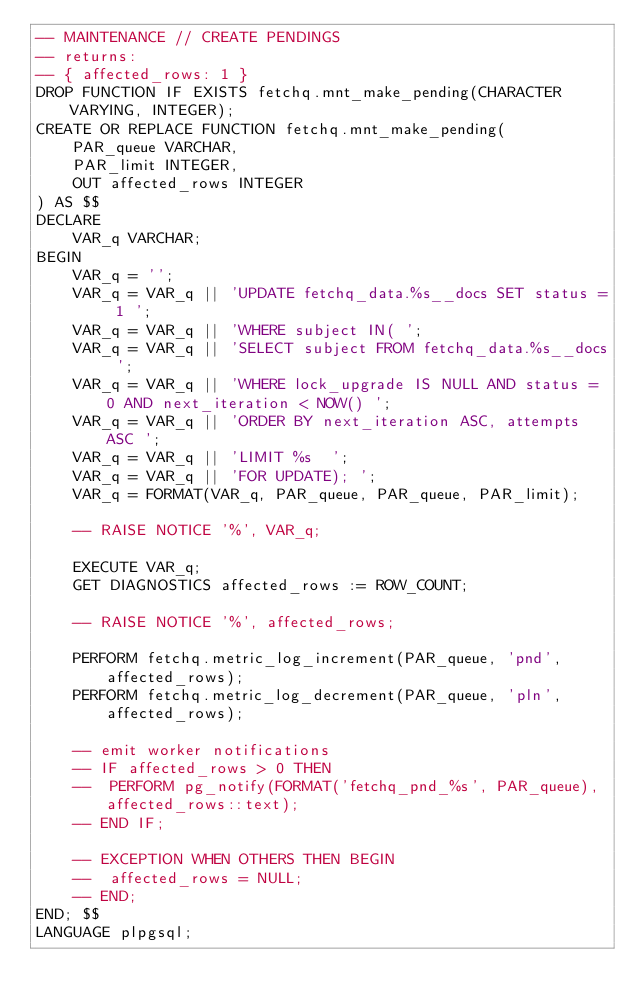Convert code to text. <code><loc_0><loc_0><loc_500><loc_500><_SQL_>-- MAINTENANCE // CREATE PENDINGS
-- returns:
-- { affected_rows: 1 }
DROP FUNCTION IF EXISTS fetchq.mnt_make_pending(CHARACTER VARYING, INTEGER);
CREATE OR REPLACE FUNCTION fetchq.mnt_make_pending(
	PAR_queue VARCHAR,
	PAR_limit INTEGER,
	OUT affected_rows INTEGER
) AS $$
DECLARE
	VAR_q VARCHAR;
BEGIN
    VAR_q = '';
	VAR_q = VAR_q || 'UPDATE fetchq_data.%s__docs SET status = 1 ';
	VAR_q = VAR_q || 'WHERE subject IN( ';
	VAR_q = VAR_q || 'SELECT subject FROM fetchq_data.%s__docs ';
	VAR_q = VAR_q || 'WHERE lock_upgrade IS NULL AND status = 0 AND next_iteration < NOW() ';
	VAR_q = VAR_q || 'ORDER BY next_iteration ASC, attempts ASC ';
	VAR_q = VAR_q || 'LIMIT %s  ';
	VAR_q = VAR_q || 'FOR UPDATE); ';
	VAR_q = FORMAT(VAR_q, PAR_queue, PAR_queue, PAR_limit);

	-- RAISE NOTICE '%', VAR_q;

	EXECUTE VAR_q;
	GET DIAGNOSTICS affected_rows := ROW_COUNT;

    -- RAISE NOTICE '%', affected_rows;

	PERFORM fetchq.metric_log_increment(PAR_queue, 'pnd', affected_rows);
	PERFORM fetchq.metric_log_decrement(PAR_queue, 'pln', affected_rows);

	-- emit worker notifications
	-- IF affected_rows > 0 THEN
	-- 	PERFORM pg_notify(FORMAT('fetchq_pnd_%s', PAR_queue), affected_rows::text);
	-- END IF;

	-- EXCEPTION WHEN OTHERS THEN BEGIN
	-- 	affected_rows = NULL;
	-- END;
END; $$
LANGUAGE plpgsql;
</code> 